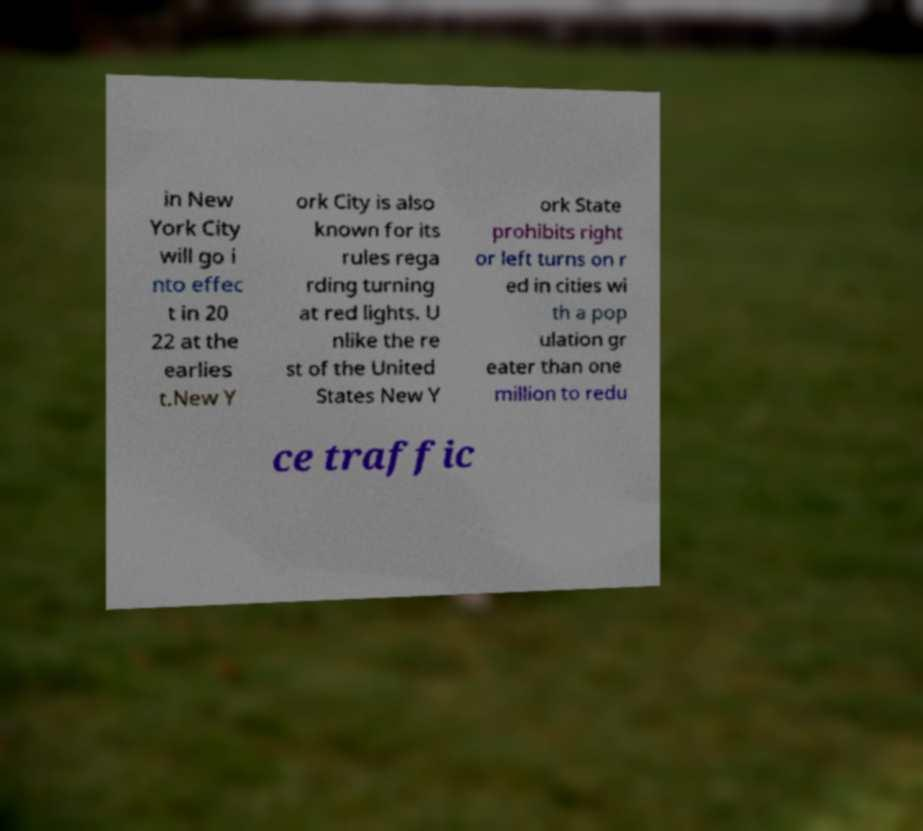Can you read and provide the text displayed in the image?This photo seems to have some interesting text. Can you extract and type it out for me? in New York City will go i nto effec t in 20 22 at the earlies t.New Y ork City is also known for its rules rega rding turning at red lights. U nlike the re st of the United States New Y ork State prohibits right or left turns on r ed in cities wi th a pop ulation gr eater than one million to redu ce traffic 